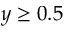Convert formula to latex. <formula><loc_0><loc_0><loc_500><loc_500>y \geq 0 . 5</formula> 